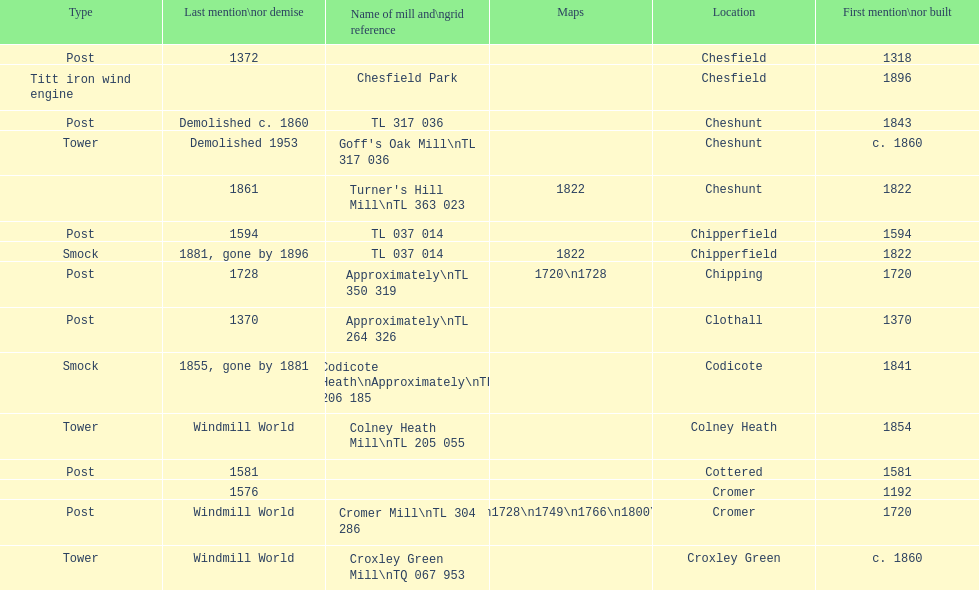How many mills were mentioned or built before 1700? 5. 